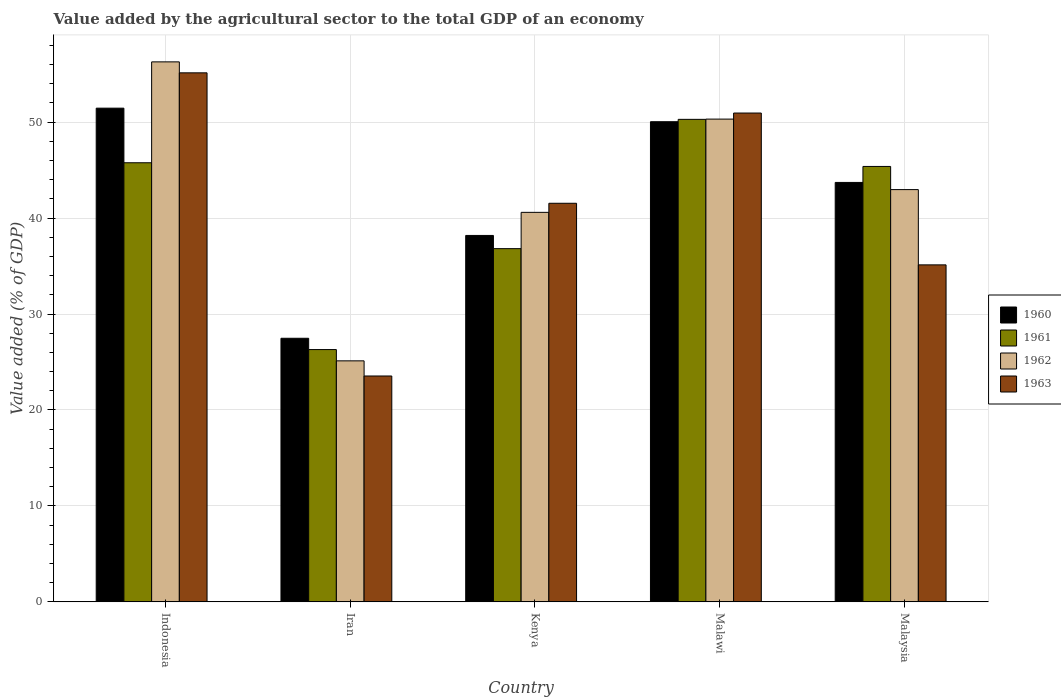How many groups of bars are there?
Provide a short and direct response. 5. Are the number of bars per tick equal to the number of legend labels?
Give a very brief answer. Yes. How many bars are there on the 1st tick from the left?
Offer a very short reply. 4. How many bars are there on the 3rd tick from the right?
Give a very brief answer. 4. What is the label of the 5th group of bars from the left?
Provide a succinct answer. Malaysia. What is the value added by the agricultural sector to the total GDP in 1960 in Malawi?
Provide a short and direct response. 50.04. Across all countries, what is the maximum value added by the agricultural sector to the total GDP in 1963?
Ensure brevity in your answer.  55.14. Across all countries, what is the minimum value added by the agricultural sector to the total GDP in 1963?
Your answer should be very brief. 23.54. In which country was the value added by the agricultural sector to the total GDP in 1962 maximum?
Offer a terse response. Indonesia. In which country was the value added by the agricultural sector to the total GDP in 1961 minimum?
Offer a very short reply. Iran. What is the total value added by the agricultural sector to the total GDP in 1960 in the graph?
Provide a succinct answer. 210.88. What is the difference between the value added by the agricultural sector to the total GDP in 1963 in Kenya and that in Malawi?
Keep it short and to the point. -9.4. What is the difference between the value added by the agricultural sector to the total GDP in 1961 in Indonesia and the value added by the agricultural sector to the total GDP in 1960 in Malawi?
Your response must be concise. -4.28. What is the average value added by the agricultural sector to the total GDP in 1961 per country?
Your response must be concise. 40.91. What is the difference between the value added by the agricultural sector to the total GDP of/in 1960 and value added by the agricultural sector to the total GDP of/in 1962 in Malawi?
Your response must be concise. -0.27. In how many countries, is the value added by the agricultural sector to the total GDP in 1960 greater than 50 %?
Ensure brevity in your answer.  2. What is the ratio of the value added by the agricultural sector to the total GDP in 1960 in Kenya to that in Malawi?
Offer a very short reply. 0.76. Is the value added by the agricultural sector to the total GDP in 1962 in Indonesia less than that in Malaysia?
Provide a short and direct response. No. What is the difference between the highest and the second highest value added by the agricultural sector to the total GDP in 1960?
Ensure brevity in your answer.  -6.33. What is the difference between the highest and the lowest value added by the agricultural sector to the total GDP in 1960?
Offer a very short reply. 23.98. What does the 2nd bar from the left in Kenya represents?
Give a very brief answer. 1961. Are all the bars in the graph horizontal?
Ensure brevity in your answer.  No. What is the difference between two consecutive major ticks on the Y-axis?
Give a very brief answer. 10. Does the graph contain any zero values?
Offer a very short reply. No. What is the title of the graph?
Provide a succinct answer. Value added by the agricultural sector to the total GDP of an economy. What is the label or title of the Y-axis?
Your response must be concise. Value added (% of GDP). What is the Value added (% of GDP) of 1960 in Indonesia?
Make the answer very short. 51.46. What is the Value added (% of GDP) of 1961 in Indonesia?
Ensure brevity in your answer.  45.77. What is the Value added (% of GDP) in 1962 in Indonesia?
Your answer should be very brief. 56.28. What is the Value added (% of GDP) in 1963 in Indonesia?
Offer a terse response. 55.14. What is the Value added (% of GDP) of 1960 in Iran?
Offer a very short reply. 27.47. What is the Value added (% of GDP) of 1961 in Iran?
Your answer should be very brief. 26.3. What is the Value added (% of GDP) of 1962 in Iran?
Make the answer very short. 25.12. What is the Value added (% of GDP) in 1963 in Iran?
Your answer should be very brief. 23.54. What is the Value added (% of GDP) of 1960 in Kenya?
Keep it short and to the point. 38.19. What is the Value added (% of GDP) of 1961 in Kenya?
Keep it short and to the point. 36.82. What is the Value added (% of GDP) in 1962 in Kenya?
Your answer should be very brief. 40.6. What is the Value added (% of GDP) of 1963 in Kenya?
Offer a terse response. 41.54. What is the Value added (% of GDP) of 1960 in Malawi?
Provide a succinct answer. 50.04. What is the Value added (% of GDP) in 1961 in Malawi?
Your answer should be compact. 50.29. What is the Value added (% of GDP) in 1962 in Malawi?
Your answer should be compact. 50.32. What is the Value added (% of GDP) in 1963 in Malawi?
Keep it short and to the point. 50.95. What is the Value added (% of GDP) of 1960 in Malaysia?
Ensure brevity in your answer.  43.72. What is the Value added (% of GDP) of 1961 in Malaysia?
Your answer should be compact. 45.38. What is the Value added (% of GDP) in 1962 in Malaysia?
Offer a very short reply. 42.97. What is the Value added (% of GDP) in 1963 in Malaysia?
Make the answer very short. 35.12. Across all countries, what is the maximum Value added (% of GDP) of 1960?
Offer a terse response. 51.46. Across all countries, what is the maximum Value added (% of GDP) of 1961?
Make the answer very short. 50.29. Across all countries, what is the maximum Value added (% of GDP) in 1962?
Keep it short and to the point. 56.28. Across all countries, what is the maximum Value added (% of GDP) in 1963?
Offer a very short reply. 55.14. Across all countries, what is the minimum Value added (% of GDP) of 1960?
Make the answer very short. 27.47. Across all countries, what is the minimum Value added (% of GDP) of 1961?
Your answer should be very brief. 26.3. Across all countries, what is the minimum Value added (% of GDP) of 1962?
Offer a very short reply. 25.12. Across all countries, what is the minimum Value added (% of GDP) of 1963?
Your answer should be compact. 23.54. What is the total Value added (% of GDP) in 1960 in the graph?
Your answer should be compact. 210.88. What is the total Value added (% of GDP) in 1961 in the graph?
Keep it short and to the point. 204.55. What is the total Value added (% of GDP) in 1962 in the graph?
Give a very brief answer. 215.28. What is the total Value added (% of GDP) in 1963 in the graph?
Keep it short and to the point. 206.3. What is the difference between the Value added (% of GDP) in 1960 in Indonesia and that in Iran?
Provide a short and direct response. 23.98. What is the difference between the Value added (% of GDP) in 1961 in Indonesia and that in Iran?
Your response must be concise. 19.47. What is the difference between the Value added (% of GDP) of 1962 in Indonesia and that in Iran?
Provide a succinct answer. 31.16. What is the difference between the Value added (% of GDP) of 1963 in Indonesia and that in Iran?
Make the answer very short. 31.6. What is the difference between the Value added (% of GDP) in 1960 in Indonesia and that in Kenya?
Your response must be concise. 13.26. What is the difference between the Value added (% of GDP) of 1961 in Indonesia and that in Kenya?
Your answer should be very brief. 8.95. What is the difference between the Value added (% of GDP) in 1962 in Indonesia and that in Kenya?
Your answer should be compact. 15.68. What is the difference between the Value added (% of GDP) of 1963 in Indonesia and that in Kenya?
Ensure brevity in your answer.  13.59. What is the difference between the Value added (% of GDP) of 1960 in Indonesia and that in Malawi?
Make the answer very short. 1.41. What is the difference between the Value added (% of GDP) of 1961 in Indonesia and that in Malawi?
Provide a succinct answer. -4.52. What is the difference between the Value added (% of GDP) of 1962 in Indonesia and that in Malawi?
Offer a very short reply. 5.96. What is the difference between the Value added (% of GDP) in 1963 in Indonesia and that in Malawi?
Provide a succinct answer. 4.19. What is the difference between the Value added (% of GDP) in 1960 in Indonesia and that in Malaysia?
Give a very brief answer. 7.74. What is the difference between the Value added (% of GDP) in 1961 in Indonesia and that in Malaysia?
Keep it short and to the point. 0.38. What is the difference between the Value added (% of GDP) in 1962 in Indonesia and that in Malaysia?
Your response must be concise. 13.31. What is the difference between the Value added (% of GDP) in 1963 in Indonesia and that in Malaysia?
Give a very brief answer. 20.02. What is the difference between the Value added (% of GDP) in 1960 in Iran and that in Kenya?
Your answer should be very brief. -10.72. What is the difference between the Value added (% of GDP) in 1961 in Iran and that in Kenya?
Ensure brevity in your answer.  -10.52. What is the difference between the Value added (% of GDP) of 1962 in Iran and that in Kenya?
Offer a terse response. -15.48. What is the difference between the Value added (% of GDP) of 1963 in Iran and that in Kenya?
Provide a succinct answer. -18. What is the difference between the Value added (% of GDP) of 1960 in Iran and that in Malawi?
Keep it short and to the point. -22.57. What is the difference between the Value added (% of GDP) of 1961 in Iran and that in Malawi?
Your response must be concise. -24. What is the difference between the Value added (% of GDP) in 1962 in Iran and that in Malawi?
Make the answer very short. -25.2. What is the difference between the Value added (% of GDP) of 1963 in Iran and that in Malawi?
Ensure brevity in your answer.  -27.41. What is the difference between the Value added (% of GDP) in 1960 in Iran and that in Malaysia?
Keep it short and to the point. -16.24. What is the difference between the Value added (% of GDP) of 1961 in Iran and that in Malaysia?
Provide a short and direct response. -19.09. What is the difference between the Value added (% of GDP) in 1962 in Iran and that in Malaysia?
Offer a very short reply. -17.85. What is the difference between the Value added (% of GDP) in 1963 in Iran and that in Malaysia?
Provide a short and direct response. -11.58. What is the difference between the Value added (% of GDP) of 1960 in Kenya and that in Malawi?
Keep it short and to the point. -11.85. What is the difference between the Value added (% of GDP) of 1961 in Kenya and that in Malawi?
Offer a terse response. -13.47. What is the difference between the Value added (% of GDP) in 1962 in Kenya and that in Malawi?
Your answer should be very brief. -9.72. What is the difference between the Value added (% of GDP) of 1963 in Kenya and that in Malawi?
Your answer should be compact. -9.4. What is the difference between the Value added (% of GDP) in 1960 in Kenya and that in Malaysia?
Your answer should be very brief. -5.52. What is the difference between the Value added (% of GDP) in 1961 in Kenya and that in Malaysia?
Make the answer very short. -8.57. What is the difference between the Value added (% of GDP) of 1962 in Kenya and that in Malaysia?
Offer a very short reply. -2.37. What is the difference between the Value added (% of GDP) in 1963 in Kenya and that in Malaysia?
Your answer should be compact. 6.42. What is the difference between the Value added (% of GDP) in 1960 in Malawi and that in Malaysia?
Ensure brevity in your answer.  6.33. What is the difference between the Value added (% of GDP) in 1961 in Malawi and that in Malaysia?
Your response must be concise. 4.91. What is the difference between the Value added (% of GDP) in 1962 in Malawi and that in Malaysia?
Make the answer very short. 7.35. What is the difference between the Value added (% of GDP) in 1963 in Malawi and that in Malaysia?
Provide a succinct answer. 15.83. What is the difference between the Value added (% of GDP) in 1960 in Indonesia and the Value added (% of GDP) in 1961 in Iran?
Ensure brevity in your answer.  25.16. What is the difference between the Value added (% of GDP) in 1960 in Indonesia and the Value added (% of GDP) in 1962 in Iran?
Your answer should be very brief. 26.34. What is the difference between the Value added (% of GDP) in 1960 in Indonesia and the Value added (% of GDP) in 1963 in Iran?
Your answer should be compact. 27.91. What is the difference between the Value added (% of GDP) of 1961 in Indonesia and the Value added (% of GDP) of 1962 in Iran?
Your answer should be very brief. 20.65. What is the difference between the Value added (% of GDP) in 1961 in Indonesia and the Value added (% of GDP) in 1963 in Iran?
Provide a short and direct response. 22.22. What is the difference between the Value added (% of GDP) in 1962 in Indonesia and the Value added (% of GDP) in 1963 in Iran?
Make the answer very short. 32.74. What is the difference between the Value added (% of GDP) of 1960 in Indonesia and the Value added (% of GDP) of 1961 in Kenya?
Ensure brevity in your answer.  14.64. What is the difference between the Value added (% of GDP) of 1960 in Indonesia and the Value added (% of GDP) of 1962 in Kenya?
Give a very brief answer. 10.86. What is the difference between the Value added (% of GDP) of 1960 in Indonesia and the Value added (% of GDP) of 1963 in Kenya?
Provide a short and direct response. 9.91. What is the difference between the Value added (% of GDP) in 1961 in Indonesia and the Value added (% of GDP) in 1962 in Kenya?
Keep it short and to the point. 5.17. What is the difference between the Value added (% of GDP) of 1961 in Indonesia and the Value added (% of GDP) of 1963 in Kenya?
Your answer should be very brief. 4.22. What is the difference between the Value added (% of GDP) of 1962 in Indonesia and the Value added (% of GDP) of 1963 in Kenya?
Provide a short and direct response. 14.74. What is the difference between the Value added (% of GDP) of 1960 in Indonesia and the Value added (% of GDP) of 1961 in Malawi?
Make the answer very short. 1.17. What is the difference between the Value added (% of GDP) of 1960 in Indonesia and the Value added (% of GDP) of 1962 in Malawi?
Give a very brief answer. 1.14. What is the difference between the Value added (% of GDP) in 1960 in Indonesia and the Value added (% of GDP) in 1963 in Malawi?
Ensure brevity in your answer.  0.51. What is the difference between the Value added (% of GDP) of 1961 in Indonesia and the Value added (% of GDP) of 1962 in Malawi?
Your answer should be compact. -4.55. What is the difference between the Value added (% of GDP) of 1961 in Indonesia and the Value added (% of GDP) of 1963 in Malawi?
Keep it short and to the point. -5.18. What is the difference between the Value added (% of GDP) of 1962 in Indonesia and the Value added (% of GDP) of 1963 in Malawi?
Ensure brevity in your answer.  5.33. What is the difference between the Value added (% of GDP) in 1960 in Indonesia and the Value added (% of GDP) in 1961 in Malaysia?
Keep it short and to the point. 6.07. What is the difference between the Value added (% of GDP) in 1960 in Indonesia and the Value added (% of GDP) in 1962 in Malaysia?
Your response must be concise. 8.49. What is the difference between the Value added (% of GDP) in 1960 in Indonesia and the Value added (% of GDP) in 1963 in Malaysia?
Make the answer very short. 16.33. What is the difference between the Value added (% of GDP) of 1961 in Indonesia and the Value added (% of GDP) of 1962 in Malaysia?
Ensure brevity in your answer.  2.8. What is the difference between the Value added (% of GDP) in 1961 in Indonesia and the Value added (% of GDP) in 1963 in Malaysia?
Your answer should be compact. 10.64. What is the difference between the Value added (% of GDP) in 1962 in Indonesia and the Value added (% of GDP) in 1963 in Malaysia?
Offer a terse response. 21.16. What is the difference between the Value added (% of GDP) in 1960 in Iran and the Value added (% of GDP) in 1961 in Kenya?
Ensure brevity in your answer.  -9.34. What is the difference between the Value added (% of GDP) of 1960 in Iran and the Value added (% of GDP) of 1962 in Kenya?
Give a very brief answer. -13.12. What is the difference between the Value added (% of GDP) in 1960 in Iran and the Value added (% of GDP) in 1963 in Kenya?
Keep it short and to the point. -14.07. What is the difference between the Value added (% of GDP) in 1961 in Iran and the Value added (% of GDP) in 1962 in Kenya?
Make the answer very short. -14.3. What is the difference between the Value added (% of GDP) in 1961 in Iran and the Value added (% of GDP) in 1963 in Kenya?
Offer a terse response. -15.25. What is the difference between the Value added (% of GDP) in 1962 in Iran and the Value added (% of GDP) in 1963 in Kenya?
Offer a terse response. -16.42. What is the difference between the Value added (% of GDP) in 1960 in Iran and the Value added (% of GDP) in 1961 in Malawi?
Give a very brief answer. -22.82. What is the difference between the Value added (% of GDP) in 1960 in Iran and the Value added (% of GDP) in 1962 in Malawi?
Your answer should be compact. -22.84. What is the difference between the Value added (% of GDP) in 1960 in Iran and the Value added (% of GDP) in 1963 in Malawi?
Provide a short and direct response. -23.48. What is the difference between the Value added (% of GDP) of 1961 in Iran and the Value added (% of GDP) of 1962 in Malawi?
Your answer should be compact. -24.02. What is the difference between the Value added (% of GDP) in 1961 in Iran and the Value added (% of GDP) in 1963 in Malawi?
Offer a very short reply. -24.65. What is the difference between the Value added (% of GDP) in 1962 in Iran and the Value added (% of GDP) in 1963 in Malawi?
Offer a terse response. -25.83. What is the difference between the Value added (% of GDP) of 1960 in Iran and the Value added (% of GDP) of 1961 in Malaysia?
Your response must be concise. -17.91. What is the difference between the Value added (% of GDP) of 1960 in Iran and the Value added (% of GDP) of 1962 in Malaysia?
Provide a short and direct response. -15.49. What is the difference between the Value added (% of GDP) of 1960 in Iran and the Value added (% of GDP) of 1963 in Malaysia?
Your response must be concise. -7.65. What is the difference between the Value added (% of GDP) in 1961 in Iran and the Value added (% of GDP) in 1962 in Malaysia?
Make the answer very short. -16.67. What is the difference between the Value added (% of GDP) in 1961 in Iran and the Value added (% of GDP) in 1963 in Malaysia?
Offer a terse response. -8.83. What is the difference between the Value added (% of GDP) in 1962 in Iran and the Value added (% of GDP) in 1963 in Malaysia?
Provide a short and direct response. -10. What is the difference between the Value added (% of GDP) in 1960 in Kenya and the Value added (% of GDP) in 1961 in Malawi?
Your answer should be compact. -12.1. What is the difference between the Value added (% of GDP) in 1960 in Kenya and the Value added (% of GDP) in 1962 in Malawi?
Make the answer very short. -12.12. What is the difference between the Value added (% of GDP) of 1960 in Kenya and the Value added (% of GDP) of 1963 in Malawi?
Offer a very short reply. -12.76. What is the difference between the Value added (% of GDP) in 1961 in Kenya and the Value added (% of GDP) in 1962 in Malawi?
Offer a very short reply. -13.5. What is the difference between the Value added (% of GDP) in 1961 in Kenya and the Value added (% of GDP) in 1963 in Malawi?
Give a very brief answer. -14.13. What is the difference between the Value added (% of GDP) of 1962 in Kenya and the Value added (% of GDP) of 1963 in Malawi?
Ensure brevity in your answer.  -10.35. What is the difference between the Value added (% of GDP) of 1960 in Kenya and the Value added (% of GDP) of 1961 in Malaysia?
Your response must be concise. -7.19. What is the difference between the Value added (% of GDP) of 1960 in Kenya and the Value added (% of GDP) of 1962 in Malaysia?
Provide a short and direct response. -4.78. What is the difference between the Value added (% of GDP) of 1960 in Kenya and the Value added (% of GDP) of 1963 in Malaysia?
Your answer should be compact. 3.07. What is the difference between the Value added (% of GDP) of 1961 in Kenya and the Value added (% of GDP) of 1962 in Malaysia?
Ensure brevity in your answer.  -6.15. What is the difference between the Value added (% of GDP) in 1961 in Kenya and the Value added (% of GDP) in 1963 in Malaysia?
Your response must be concise. 1.69. What is the difference between the Value added (% of GDP) of 1962 in Kenya and the Value added (% of GDP) of 1963 in Malaysia?
Provide a short and direct response. 5.47. What is the difference between the Value added (% of GDP) in 1960 in Malawi and the Value added (% of GDP) in 1961 in Malaysia?
Your answer should be compact. 4.66. What is the difference between the Value added (% of GDP) in 1960 in Malawi and the Value added (% of GDP) in 1962 in Malaysia?
Offer a very short reply. 7.08. What is the difference between the Value added (% of GDP) in 1960 in Malawi and the Value added (% of GDP) in 1963 in Malaysia?
Your answer should be very brief. 14.92. What is the difference between the Value added (% of GDP) of 1961 in Malawi and the Value added (% of GDP) of 1962 in Malaysia?
Keep it short and to the point. 7.32. What is the difference between the Value added (% of GDP) in 1961 in Malawi and the Value added (% of GDP) in 1963 in Malaysia?
Give a very brief answer. 15.17. What is the difference between the Value added (% of GDP) of 1962 in Malawi and the Value added (% of GDP) of 1963 in Malaysia?
Offer a very short reply. 15.19. What is the average Value added (% of GDP) in 1960 per country?
Offer a terse response. 42.18. What is the average Value added (% of GDP) in 1961 per country?
Make the answer very short. 40.91. What is the average Value added (% of GDP) of 1962 per country?
Make the answer very short. 43.06. What is the average Value added (% of GDP) in 1963 per country?
Make the answer very short. 41.26. What is the difference between the Value added (% of GDP) in 1960 and Value added (% of GDP) in 1961 in Indonesia?
Provide a succinct answer. 5.69. What is the difference between the Value added (% of GDP) of 1960 and Value added (% of GDP) of 1962 in Indonesia?
Your answer should be compact. -4.82. What is the difference between the Value added (% of GDP) of 1960 and Value added (% of GDP) of 1963 in Indonesia?
Provide a short and direct response. -3.68. What is the difference between the Value added (% of GDP) in 1961 and Value added (% of GDP) in 1962 in Indonesia?
Give a very brief answer. -10.51. What is the difference between the Value added (% of GDP) in 1961 and Value added (% of GDP) in 1963 in Indonesia?
Your answer should be compact. -9.37. What is the difference between the Value added (% of GDP) in 1962 and Value added (% of GDP) in 1963 in Indonesia?
Provide a succinct answer. 1.14. What is the difference between the Value added (% of GDP) of 1960 and Value added (% of GDP) of 1961 in Iran?
Make the answer very short. 1.18. What is the difference between the Value added (% of GDP) of 1960 and Value added (% of GDP) of 1962 in Iran?
Your response must be concise. 2.35. What is the difference between the Value added (% of GDP) of 1960 and Value added (% of GDP) of 1963 in Iran?
Offer a very short reply. 3.93. What is the difference between the Value added (% of GDP) in 1961 and Value added (% of GDP) in 1962 in Iran?
Provide a short and direct response. 1.17. What is the difference between the Value added (% of GDP) in 1961 and Value added (% of GDP) in 1963 in Iran?
Provide a succinct answer. 2.75. What is the difference between the Value added (% of GDP) in 1962 and Value added (% of GDP) in 1963 in Iran?
Keep it short and to the point. 1.58. What is the difference between the Value added (% of GDP) in 1960 and Value added (% of GDP) in 1961 in Kenya?
Offer a terse response. 1.38. What is the difference between the Value added (% of GDP) in 1960 and Value added (% of GDP) in 1962 in Kenya?
Your answer should be compact. -2.41. What is the difference between the Value added (% of GDP) in 1960 and Value added (% of GDP) in 1963 in Kenya?
Offer a terse response. -3.35. What is the difference between the Value added (% of GDP) in 1961 and Value added (% of GDP) in 1962 in Kenya?
Give a very brief answer. -3.78. What is the difference between the Value added (% of GDP) in 1961 and Value added (% of GDP) in 1963 in Kenya?
Ensure brevity in your answer.  -4.73. What is the difference between the Value added (% of GDP) of 1962 and Value added (% of GDP) of 1963 in Kenya?
Ensure brevity in your answer.  -0.95. What is the difference between the Value added (% of GDP) of 1960 and Value added (% of GDP) of 1961 in Malawi?
Provide a succinct answer. -0.25. What is the difference between the Value added (% of GDP) in 1960 and Value added (% of GDP) in 1962 in Malawi?
Your answer should be very brief. -0.27. What is the difference between the Value added (% of GDP) of 1960 and Value added (% of GDP) of 1963 in Malawi?
Your answer should be compact. -0.9. What is the difference between the Value added (% of GDP) of 1961 and Value added (% of GDP) of 1962 in Malawi?
Provide a short and direct response. -0.03. What is the difference between the Value added (% of GDP) in 1961 and Value added (% of GDP) in 1963 in Malawi?
Your response must be concise. -0.66. What is the difference between the Value added (% of GDP) of 1962 and Value added (% of GDP) of 1963 in Malawi?
Your answer should be compact. -0.63. What is the difference between the Value added (% of GDP) in 1960 and Value added (% of GDP) in 1961 in Malaysia?
Provide a short and direct response. -1.67. What is the difference between the Value added (% of GDP) in 1960 and Value added (% of GDP) in 1962 in Malaysia?
Your response must be concise. 0.75. What is the difference between the Value added (% of GDP) in 1960 and Value added (% of GDP) in 1963 in Malaysia?
Your answer should be very brief. 8.59. What is the difference between the Value added (% of GDP) of 1961 and Value added (% of GDP) of 1962 in Malaysia?
Your answer should be compact. 2.41. What is the difference between the Value added (% of GDP) of 1961 and Value added (% of GDP) of 1963 in Malaysia?
Ensure brevity in your answer.  10.26. What is the difference between the Value added (% of GDP) in 1962 and Value added (% of GDP) in 1963 in Malaysia?
Your response must be concise. 7.84. What is the ratio of the Value added (% of GDP) in 1960 in Indonesia to that in Iran?
Your answer should be very brief. 1.87. What is the ratio of the Value added (% of GDP) in 1961 in Indonesia to that in Iran?
Your answer should be very brief. 1.74. What is the ratio of the Value added (% of GDP) in 1962 in Indonesia to that in Iran?
Your answer should be compact. 2.24. What is the ratio of the Value added (% of GDP) in 1963 in Indonesia to that in Iran?
Your response must be concise. 2.34. What is the ratio of the Value added (% of GDP) of 1960 in Indonesia to that in Kenya?
Make the answer very short. 1.35. What is the ratio of the Value added (% of GDP) of 1961 in Indonesia to that in Kenya?
Ensure brevity in your answer.  1.24. What is the ratio of the Value added (% of GDP) in 1962 in Indonesia to that in Kenya?
Your answer should be very brief. 1.39. What is the ratio of the Value added (% of GDP) in 1963 in Indonesia to that in Kenya?
Offer a terse response. 1.33. What is the ratio of the Value added (% of GDP) of 1960 in Indonesia to that in Malawi?
Your answer should be very brief. 1.03. What is the ratio of the Value added (% of GDP) in 1961 in Indonesia to that in Malawi?
Ensure brevity in your answer.  0.91. What is the ratio of the Value added (% of GDP) in 1962 in Indonesia to that in Malawi?
Make the answer very short. 1.12. What is the ratio of the Value added (% of GDP) of 1963 in Indonesia to that in Malawi?
Your response must be concise. 1.08. What is the ratio of the Value added (% of GDP) of 1960 in Indonesia to that in Malaysia?
Provide a succinct answer. 1.18. What is the ratio of the Value added (% of GDP) in 1961 in Indonesia to that in Malaysia?
Provide a succinct answer. 1.01. What is the ratio of the Value added (% of GDP) of 1962 in Indonesia to that in Malaysia?
Provide a short and direct response. 1.31. What is the ratio of the Value added (% of GDP) in 1963 in Indonesia to that in Malaysia?
Ensure brevity in your answer.  1.57. What is the ratio of the Value added (% of GDP) of 1960 in Iran to that in Kenya?
Make the answer very short. 0.72. What is the ratio of the Value added (% of GDP) in 1962 in Iran to that in Kenya?
Offer a very short reply. 0.62. What is the ratio of the Value added (% of GDP) of 1963 in Iran to that in Kenya?
Provide a short and direct response. 0.57. What is the ratio of the Value added (% of GDP) in 1960 in Iran to that in Malawi?
Give a very brief answer. 0.55. What is the ratio of the Value added (% of GDP) of 1961 in Iran to that in Malawi?
Your answer should be compact. 0.52. What is the ratio of the Value added (% of GDP) of 1962 in Iran to that in Malawi?
Your answer should be very brief. 0.5. What is the ratio of the Value added (% of GDP) of 1963 in Iran to that in Malawi?
Ensure brevity in your answer.  0.46. What is the ratio of the Value added (% of GDP) of 1960 in Iran to that in Malaysia?
Make the answer very short. 0.63. What is the ratio of the Value added (% of GDP) in 1961 in Iran to that in Malaysia?
Make the answer very short. 0.58. What is the ratio of the Value added (% of GDP) of 1962 in Iran to that in Malaysia?
Give a very brief answer. 0.58. What is the ratio of the Value added (% of GDP) of 1963 in Iran to that in Malaysia?
Your answer should be compact. 0.67. What is the ratio of the Value added (% of GDP) in 1960 in Kenya to that in Malawi?
Provide a short and direct response. 0.76. What is the ratio of the Value added (% of GDP) of 1961 in Kenya to that in Malawi?
Offer a very short reply. 0.73. What is the ratio of the Value added (% of GDP) of 1962 in Kenya to that in Malawi?
Provide a succinct answer. 0.81. What is the ratio of the Value added (% of GDP) in 1963 in Kenya to that in Malawi?
Offer a terse response. 0.82. What is the ratio of the Value added (% of GDP) in 1960 in Kenya to that in Malaysia?
Offer a very short reply. 0.87. What is the ratio of the Value added (% of GDP) in 1961 in Kenya to that in Malaysia?
Provide a succinct answer. 0.81. What is the ratio of the Value added (% of GDP) in 1962 in Kenya to that in Malaysia?
Ensure brevity in your answer.  0.94. What is the ratio of the Value added (% of GDP) of 1963 in Kenya to that in Malaysia?
Give a very brief answer. 1.18. What is the ratio of the Value added (% of GDP) in 1960 in Malawi to that in Malaysia?
Keep it short and to the point. 1.14. What is the ratio of the Value added (% of GDP) of 1961 in Malawi to that in Malaysia?
Keep it short and to the point. 1.11. What is the ratio of the Value added (% of GDP) of 1962 in Malawi to that in Malaysia?
Give a very brief answer. 1.17. What is the ratio of the Value added (% of GDP) of 1963 in Malawi to that in Malaysia?
Offer a terse response. 1.45. What is the difference between the highest and the second highest Value added (% of GDP) of 1960?
Offer a terse response. 1.41. What is the difference between the highest and the second highest Value added (% of GDP) of 1961?
Ensure brevity in your answer.  4.52. What is the difference between the highest and the second highest Value added (% of GDP) in 1962?
Your answer should be very brief. 5.96. What is the difference between the highest and the second highest Value added (% of GDP) in 1963?
Give a very brief answer. 4.19. What is the difference between the highest and the lowest Value added (% of GDP) of 1960?
Offer a very short reply. 23.98. What is the difference between the highest and the lowest Value added (% of GDP) in 1961?
Offer a very short reply. 24. What is the difference between the highest and the lowest Value added (% of GDP) in 1962?
Your answer should be compact. 31.16. What is the difference between the highest and the lowest Value added (% of GDP) in 1963?
Offer a very short reply. 31.6. 